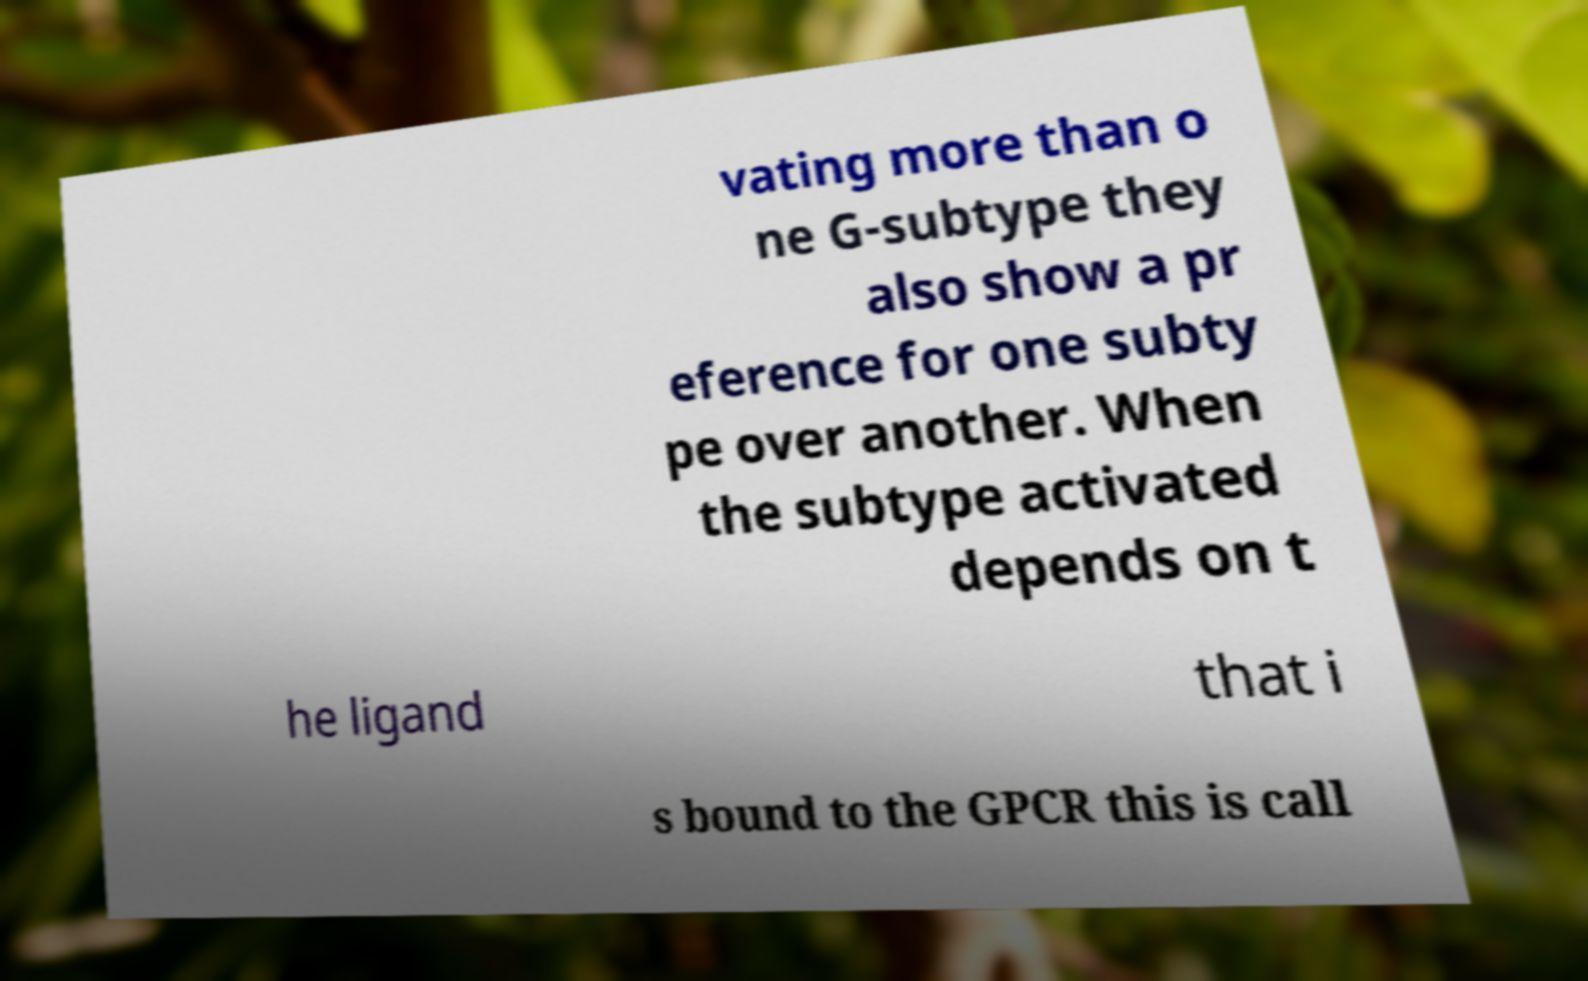Could you assist in decoding the text presented in this image and type it out clearly? vating more than o ne G-subtype they also show a pr eference for one subty pe over another. When the subtype activated depends on t he ligand that i s bound to the GPCR this is call 